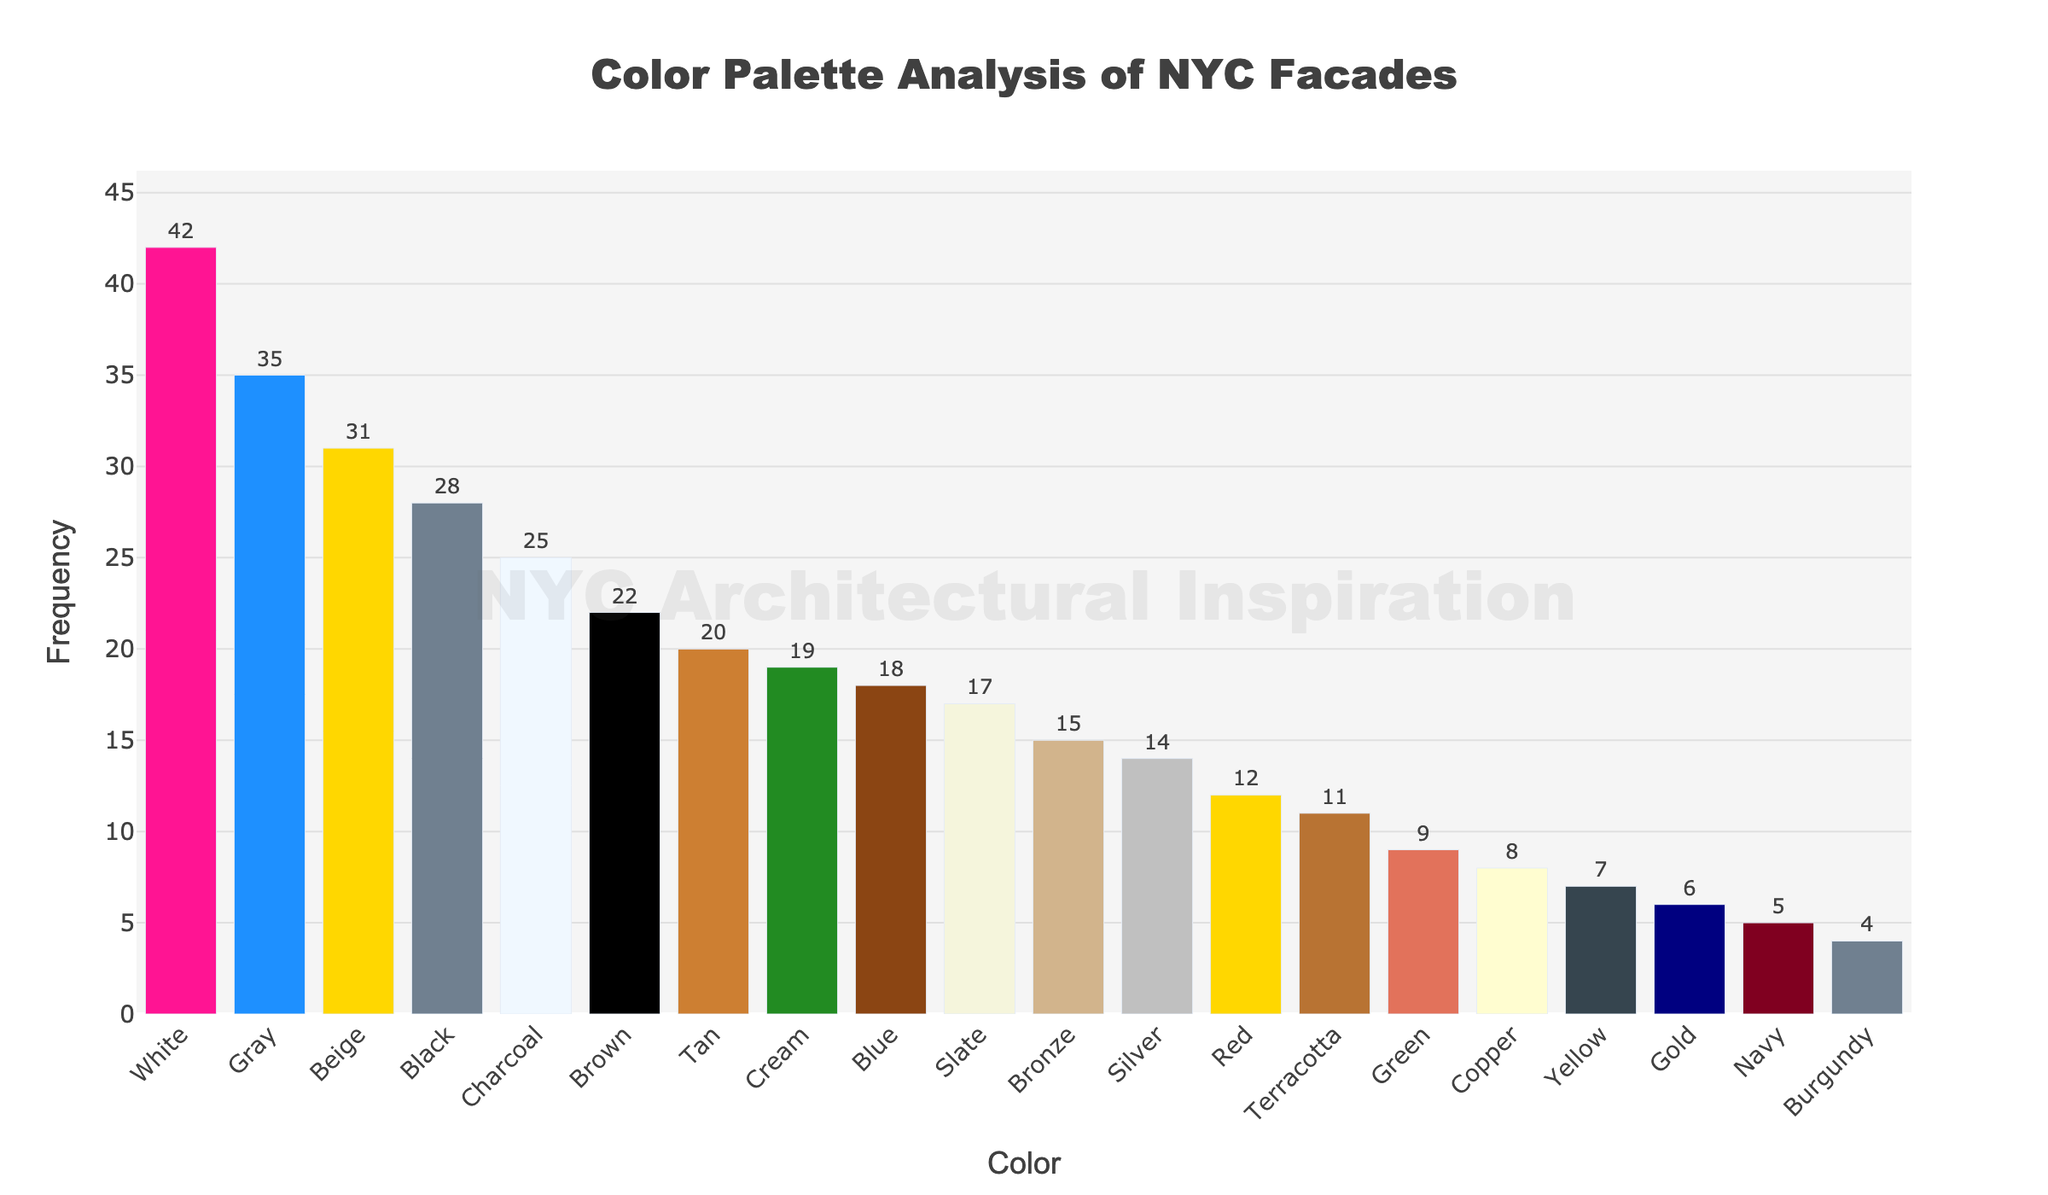Which color is used most frequently in NYC facades? By looking at the height of each bar in the bar chart, the tallest bar represents the most frequently used color. The white bar is the tallest, so white is the most frequently used color.
Answer: White How many more times is Black used compared to Silver? The frequency for Black is 28, and for Silver, it is 14. Subtracting Silver's frequency from Black's frequency gives 28 - 14 = 14.
Answer: 14 What are the top three most frequently used colors? By observing the heights of the bars and identifying the highest three, we see that White, Gray, and Beige are the top three most frequently used colors.
Answer: White, Gray, and Beige Which color has a frequency closer to 15, Bronze or Copper? The frequency of Bronze is 15, and the frequency of Copper is 8. Since Bronze matches 15 exactly, it is closer.
Answer: Bronze How many colors have a frequency greater than 20 but less than 30? By counting the bars that fall within the range of 20 to 29, we find that Black (28), Beige (31), Brown (22), and Charcoal (25) fall within this range.
Answer: 4 What is the total combined frequency of the least frequently used three colors? The least frequently used three colors are Navy (5), Burgundy (4), and Gold (6). Their combined frequency is 5 + 4 + 6 = 15.
Answer: 15 Which color has a higher frequency, Red or Green? The Red bar has a frequency of 12, and the Green bar has a frequency of 9. Comparing these values, it's clear that Red has a higher frequency.
Answer: Red What is the median frequency value of all the colors? Listing the frequency values in ascending order and finding the middle value: 4, 5, 6, 7, 8, 9, 11, 12, 14, 15, 17, 18, 19, 20, 22, 25, 28, 31, 35, 42. The middle values are 15 and 17, so the median is (15 + 17) / 2 = 16.
Answer: 16 Compare the difference in frequency between the most and least frequently used colors. The most frequently used color (White) has a frequency of 42, and the least frequently used color (Burgundy) has a frequency of 4. The difference is 42 - 4 = 38.
Answer: 38 